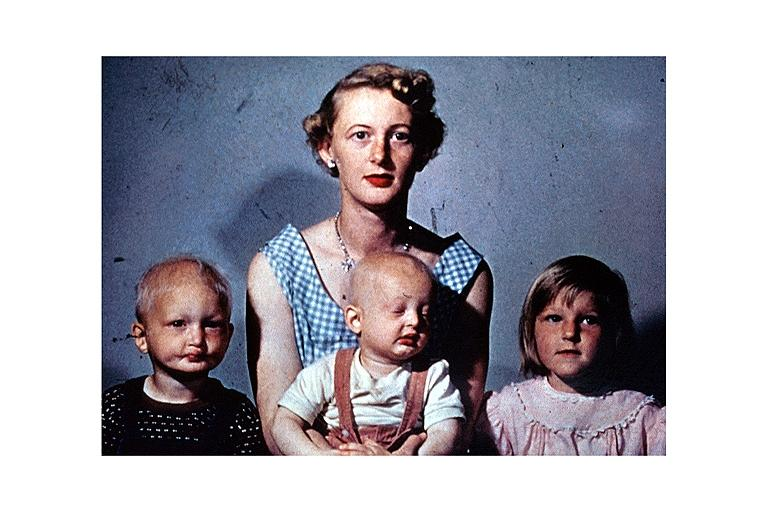does this image show anhidrotic ectodermal dysplasia?
Answer the question using a single word or phrase. Yes 